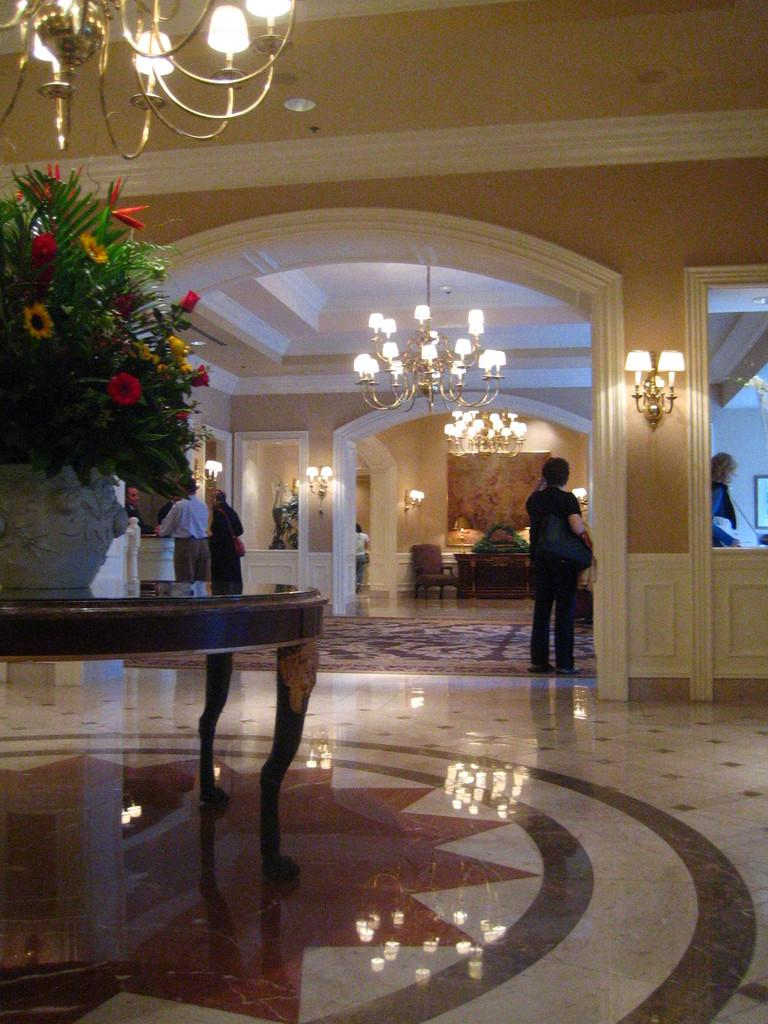What is on the table in the image? There is a plant with flowers on the table. What is above the table in the image? There are lights on top of the table. What can be seen near the table in the image? People are standing near the table. What type of furniture is present in the image? There is a chair and table in the image. What else is illuminated in the image? There are lights on the wall. Can you see a flock of birds flying over the ocean in the image? There is no flock of birds or ocean present in the image. Are there any bears visible in the image? There are no bears present in the image. 